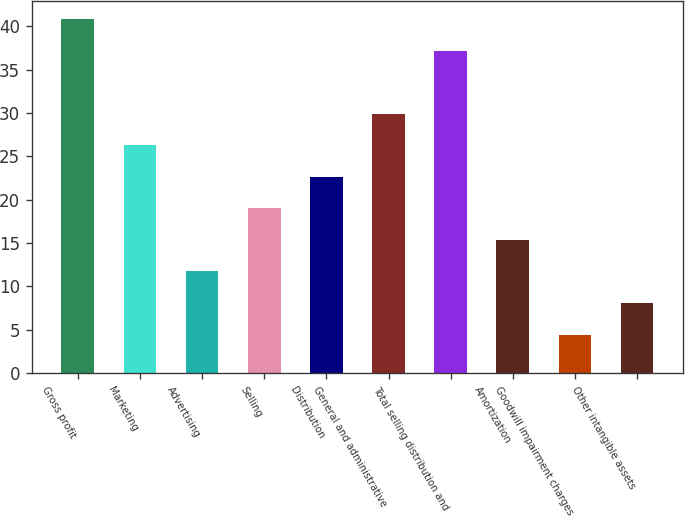Convert chart. <chart><loc_0><loc_0><loc_500><loc_500><bar_chart><fcel>Gross profit<fcel>Marketing<fcel>Advertising<fcel>Selling<fcel>Distribution<fcel>General and administrative<fcel>Total selling distribution and<fcel>Amortization<fcel>Goodwill impairment charges<fcel>Other intangible assets<nl><fcel>40.84<fcel>26.28<fcel>11.72<fcel>19<fcel>22.64<fcel>29.92<fcel>37.2<fcel>15.36<fcel>4.44<fcel>8.08<nl></chart> 